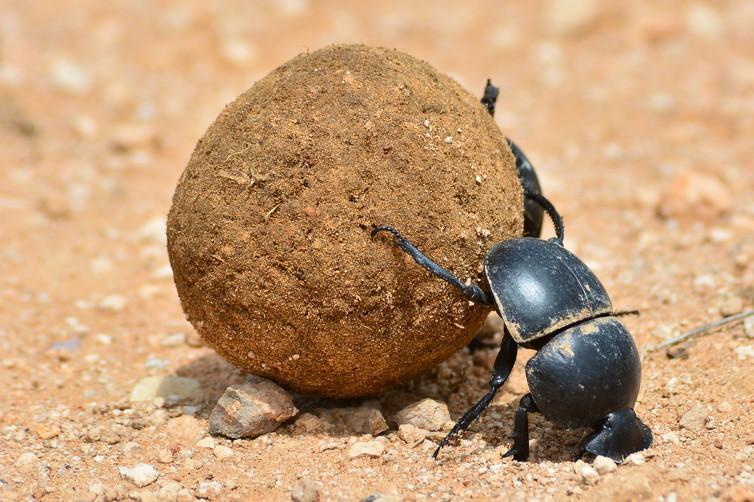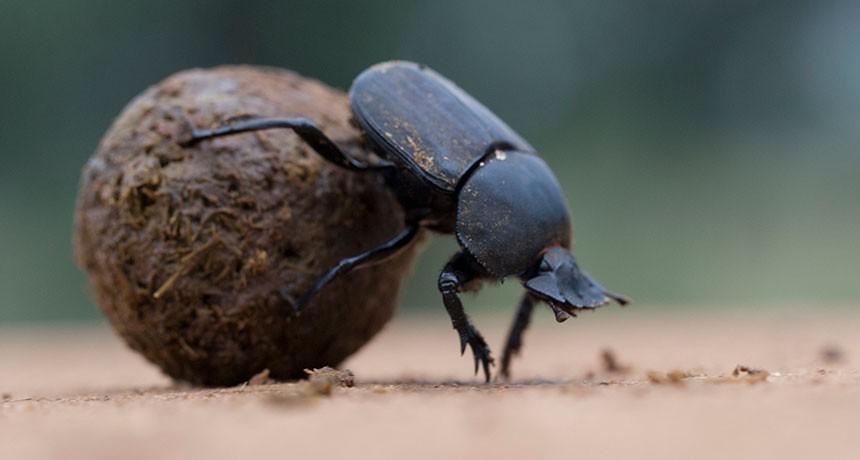The first image is the image on the left, the second image is the image on the right. Assess this claim about the two images: "There are no more than two dung beetles.". Correct or not? Answer yes or no. Yes. The first image is the image on the left, the second image is the image on the right. Examine the images to the left and right. Is the description "In one of the images, more than one beetle is seen, interacting with the 'ball'." accurate? Answer yes or no. No. 